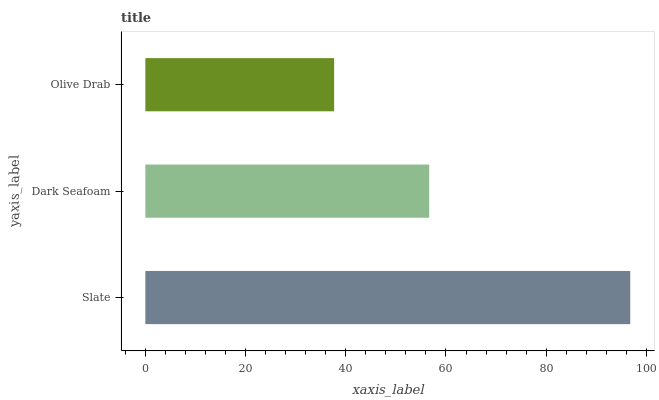Is Olive Drab the minimum?
Answer yes or no. Yes. Is Slate the maximum?
Answer yes or no. Yes. Is Dark Seafoam the minimum?
Answer yes or no. No. Is Dark Seafoam the maximum?
Answer yes or no. No. Is Slate greater than Dark Seafoam?
Answer yes or no. Yes. Is Dark Seafoam less than Slate?
Answer yes or no. Yes. Is Dark Seafoam greater than Slate?
Answer yes or no. No. Is Slate less than Dark Seafoam?
Answer yes or no. No. Is Dark Seafoam the high median?
Answer yes or no. Yes. Is Dark Seafoam the low median?
Answer yes or no. Yes. Is Olive Drab the high median?
Answer yes or no. No. Is Slate the low median?
Answer yes or no. No. 